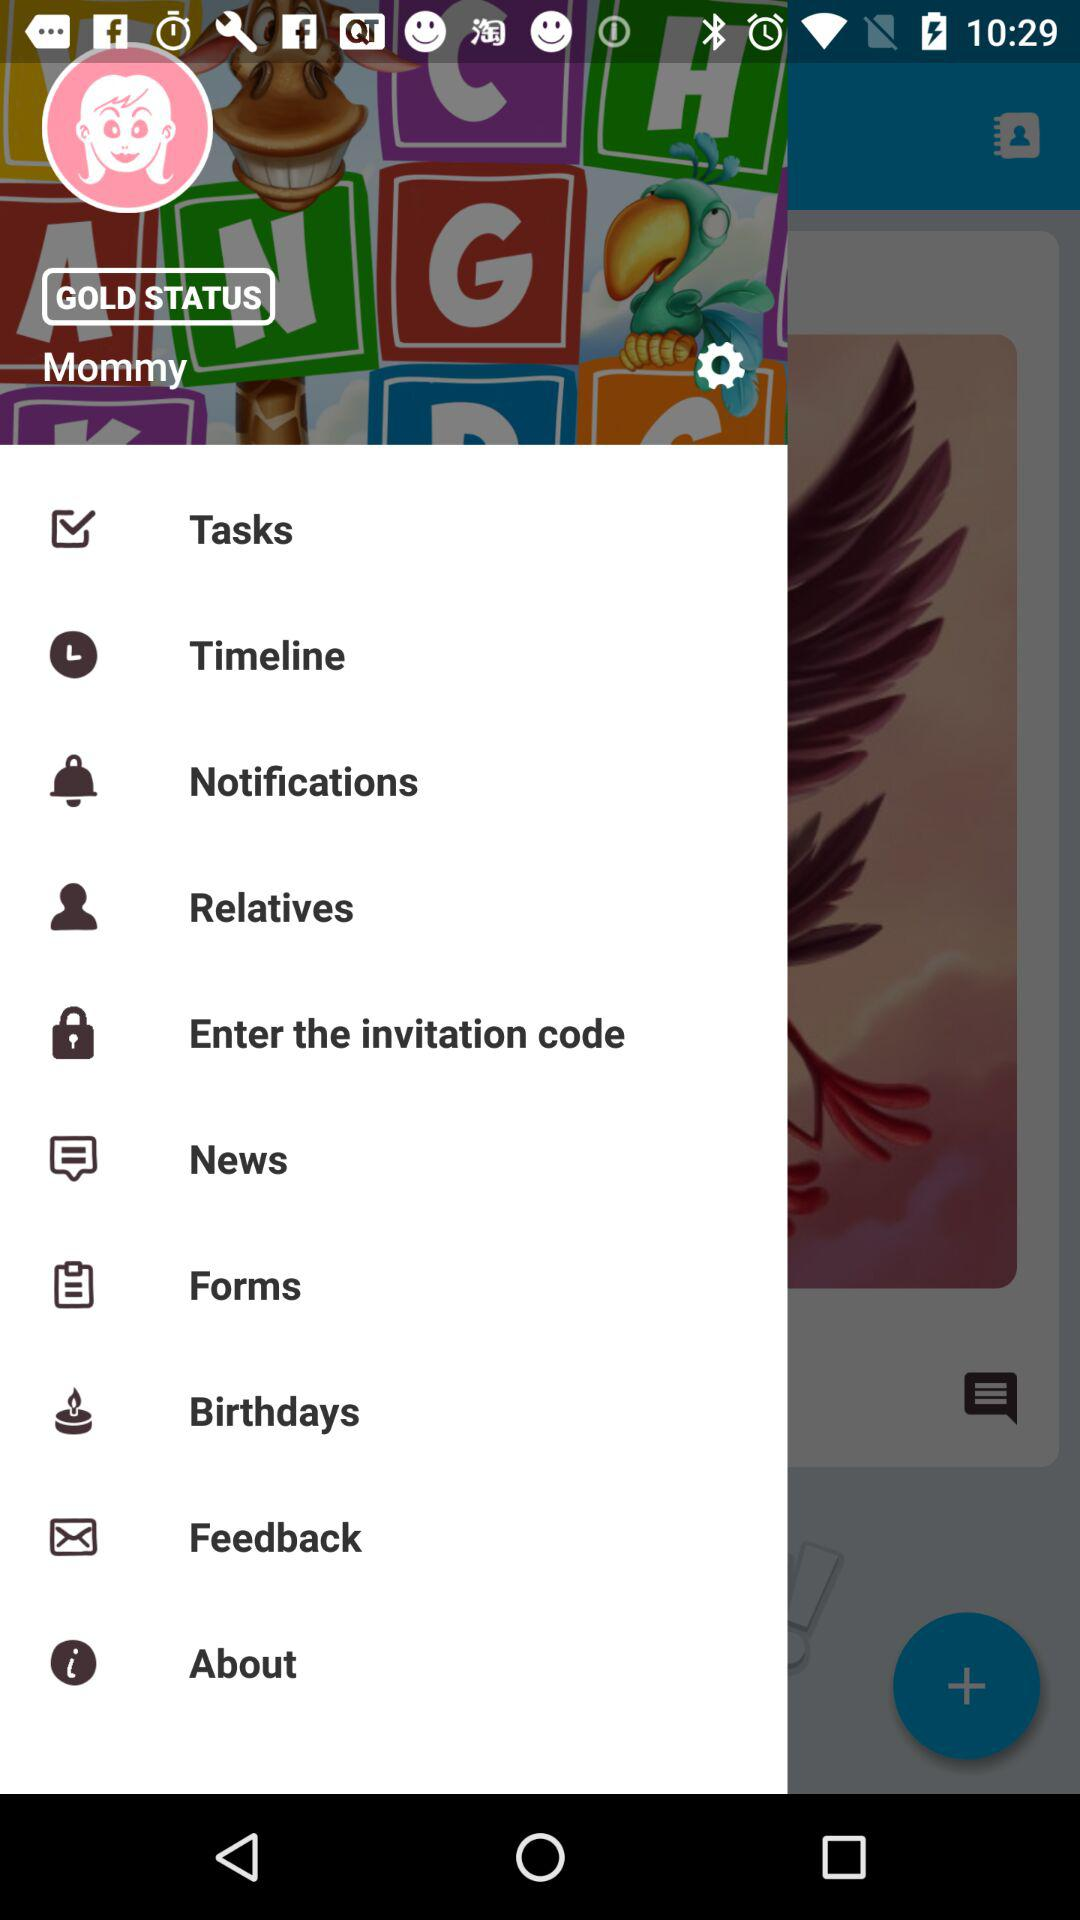What is the username? The username is Mommy. 